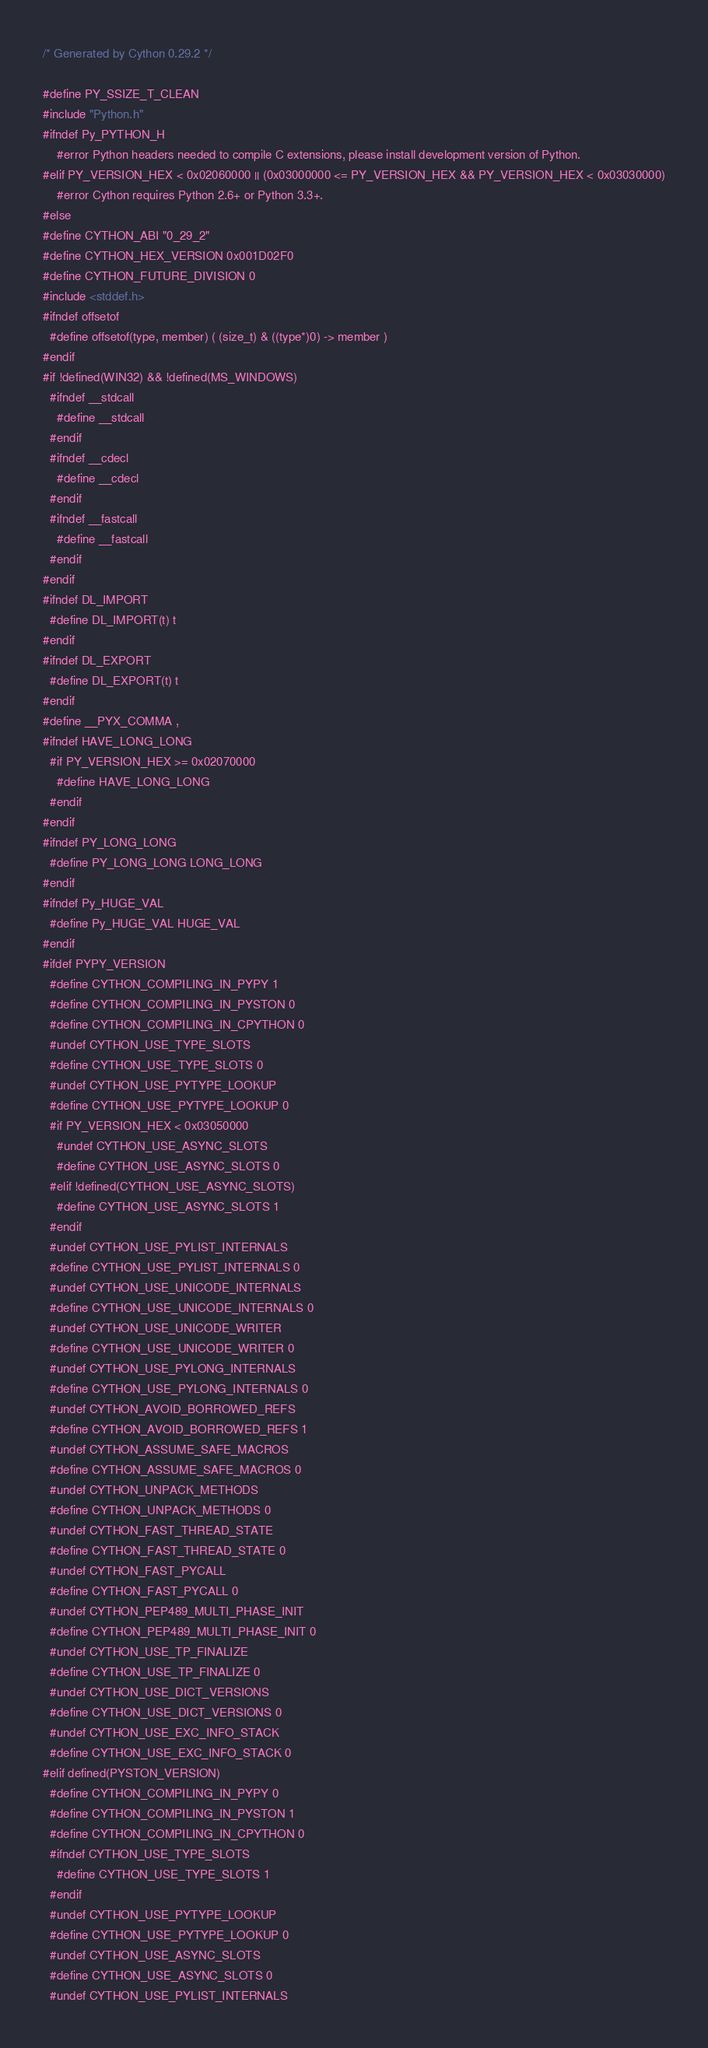Convert code to text. <code><loc_0><loc_0><loc_500><loc_500><_C++_>/* Generated by Cython 0.29.2 */

#define PY_SSIZE_T_CLEAN
#include "Python.h"
#ifndef Py_PYTHON_H
    #error Python headers needed to compile C extensions, please install development version of Python.
#elif PY_VERSION_HEX < 0x02060000 || (0x03000000 <= PY_VERSION_HEX && PY_VERSION_HEX < 0x03030000)
    #error Cython requires Python 2.6+ or Python 3.3+.
#else
#define CYTHON_ABI "0_29_2"
#define CYTHON_HEX_VERSION 0x001D02F0
#define CYTHON_FUTURE_DIVISION 0
#include <stddef.h>
#ifndef offsetof
  #define offsetof(type, member) ( (size_t) & ((type*)0) -> member )
#endif
#if !defined(WIN32) && !defined(MS_WINDOWS)
  #ifndef __stdcall
    #define __stdcall
  #endif
  #ifndef __cdecl
    #define __cdecl
  #endif
  #ifndef __fastcall
    #define __fastcall
  #endif
#endif
#ifndef DL_IMPORT
  #define DL_IMPORT(t) t
#endif
#ifndef DL_EXPORT
  #define DL_EXPORT(t) t
#endif
#define __PYX_COMMA ,
#ifndef HAVE_LONG_LONG
  #if PY_VERSION_HEX >= 0x02070000
    #define HAVE_LONG_LONG
  #endif
#endif
#ifndef PY_LONG_LONG
  #define PY_LONG_LONG LONG_LONG
#endif
#ifndef Py_HUGE_VAL
  #define Py_HUGE_VAL HUGE_VAL
#endif
#ifdef PYPY_VERSION
  #define CYTHON_COMPILING_IN_PYPY 1
  #define CYTHON_COMPILING_IN_PYSTON 0
  #define CYTHON_COMPILING_IN_CPYTHON 0
  #undef CYTHON_USE_TYPE_SLOTS
  #define CYTHON_USE_TYPE_SLOTS 0
  #undef CYTHON_USE_PYTYPE_LOOKUP
  #define CYTHON_USE_PYTYPE_LOOKUP 0
  #if PY_VERSION_HEX < 0x03050000
    #undef CYTHON_USE_ASYNC_SLOTS
    #define CYTHON_USE_ASYNC_SLOTS 0
  #elif !defined(CYTHON_USE_ASYNC_SLOTS)
    #define CYTHON_USE_ASYNC_SLOTS 1
  #endif
  #undef CYTHON_USE_PYLIST_INTERNALS
  #define CYTHON_USE_PYLIST_INTERNALS 0
  #undef CYTHON_USE_UNICODE_INTERNALS
  #define CYTHON_USE_UNICODE_INTERNALS 0
  #undef CYTHON_USE_UNICODE_WRITER
  #define CYTHON_USE_UNICODE_WRITER 0
  #undef CYTHON_USE_PYLONG_INTERNALS
  #define CYTHON_USE_PYLONG_INTERNALS 0
  #undef CYTHON_AVOID_BORROWED_REFS
  #define CYTHON_AVOID_BORROWED_REFS 1
  #undef CYTHON_ASSUME_SAFE_MACROS
  #define CYTHON_ASSUME_SAFE_MACROS 0
  #undef CYTHON_UNPACK_METHODS
  #define CYTHON_UNPACK_METHODS 0
  #undef CYTHON_FAST_THREAD_STATE
  #define CYTHON_FAST_THREAD_STATE 0
  #undef CYTHON_FAST_PYCALL
  #define CYTHON_FAST_PYCALL 0
  #undef CYTHON_PEP489_MULTI_PHASE_INIT
  #define CYTHON_PEP489_MULTI_PHASE_INIT 0
  #undef CYTHON_USE_TP_FINALIZE
  #define CYTHON_USE_TP_FINALIZE 0
  #undef CYTHON_USE_DICT_VERSIONS
  #define CYTHON_USE_DICT_VERSIONS 0
  #undef CYTHON_USE_EXC_INFO_STACK
  #define CYTHON_USE_EXC_INFO_STACK 0
#elif defined(PYSTON_VERSION)
  #define CYTHON_COMPILING_IN_PYPY 0
  #define CYTHON_COMPILING_IN_PYSTON 1
  #define CYTHON_COMPILING_IN_CPYTHON 0
  #ifndef CYTHON_USE_TYPE_SLOTS
    #define CYTHON_USE_TYPE_SLOTS 1
  #endif
  #undef CYTHON_USE_PYTYPE_LOOKUP
  #define CYTHON_USE_PYTYPE_LOOKUP 0
  #undef CYTHON_USE_ASYNC_SLOTS
  #define CYTHON_USE_ASYNC_SLOTS 0
  #undef CYTHON_USE_PYLIST_INTERNALS</code> 